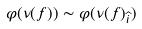Convert formula to latex. <formula><loc_0><loc_0><loc_500><loc_500>\varphi ( \nu ( f ) ) \sim \varphi ( \nu ( f ) _ { \widehat { i } } )</formula> 